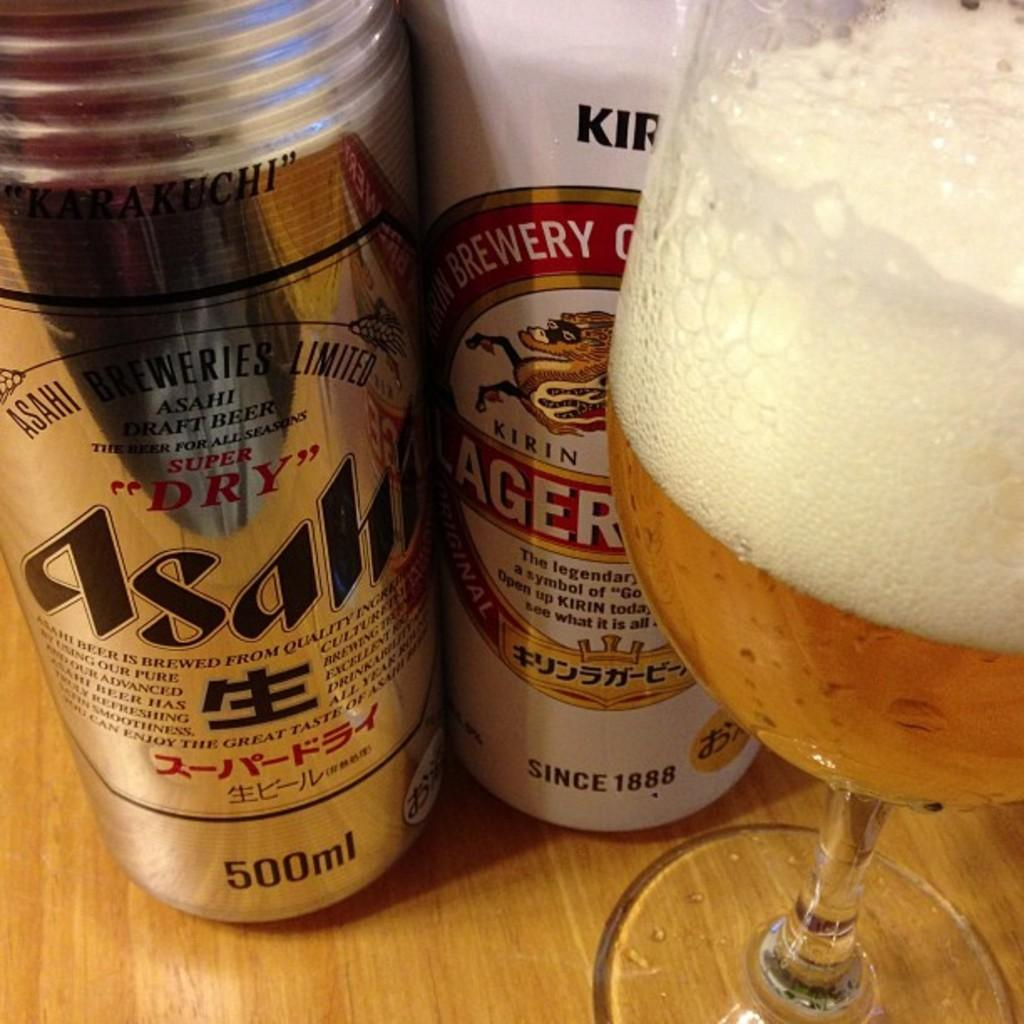<image>
Relay a brief, clear account of the picture shown. Two cans of beer, one with 500 ml and the other founded in 1888 beside a filled glass. 